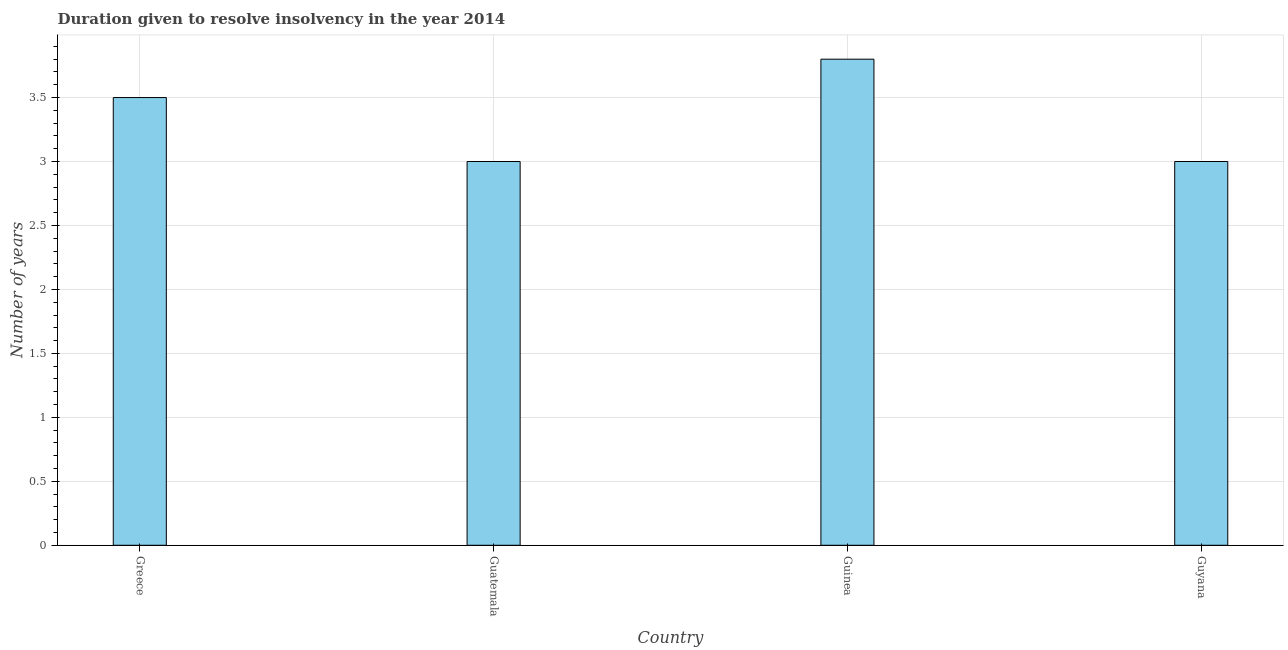Does the graph contain any zero values?
Your response must be concise. No. Does the graph contain grids?
Provide a succinct answer. Yes. What is the title of the graph?
Your response must be concise. Duration given to resolve insolvency in the year 2014. What is the label or title of the X-axis?
Give a very brief answer. Country. What is the label or title of the Y-axis?
Make the answer very short. Number of years. What is the number of years to resolve insolvency in Greece?
Ensure brevity in your answer.  3.5. Across all countries, what is the minimum number of years to resolve insolvency?
Your answer should be compact. 3. In which country was the number of years to resolve insolvency maximum?
Give a very brief answer. Guinea. In which country was the number of years to resolve insolvency minimum?
Provide a succinct answer. Guatemala. What is the average number of years to resolve insolvency per country?
Ensure brevity in your answer.  3.33. What is the median number of years to resolve insolvency?
Your answer should be very brief. 3.25. What is the ratio of the number of years to resolve insolvency in Guatemala to that in Guyana?
Your answer should be compact. 1. Is the number of years to resolve insolvency in Guatemala less than that in Guyana?
Ensure brevity in your answer.  No. Is the difference between the number of years to resolve insolvency in Guinea and Guyana greater than the difference between any two countries?
Provide a succinct answer. Yes. What is the difference between the highest and the second highest number of years to resolve insolvency?
Keep it short and to the point. 0.3. In how many countries, is the number of years to resolve insolvency greater than the average number of years to resolve insolvency taken over all countries?
Your response must be concise. 2. How many bars are there?
Offer a very short reply. 4. Are all the bars in the graph horizontal?
Offer a very short reply. No. How many countries are there in the graph?
Ensure brevity in your answer.  4. What is the difference between two consecutive major ticks on the Y-axis?
Ensure brevity in your answer.  0.5. What is the Number of years in Guinea?
Give a very brief answer. 3.8. What is the Number of years of Guyana?
Give a very brief answer. 3. What is the difference between the Number of years in Guatemala and Guinea?
Make the answer very short. -0.8. What is the difference between the Number of years in Guatemala and Guyana?
Offer a terse response. 0. What is the difference between the Number of years in Guinea and Guyana?
Keep it short and to the point. 0.8. What is the ratio of the Number of years in Greece to that in Guatemala?
Give a very brief answer. 1.17. What is the ratio of the Number of years in Greece to that in Guinea?
Your response must be concise. 0.92. What is the ratio of the Number of years in Greece to that in Guyana?
Offer a very short reply. 1.17. What is the ratio of the Number of years in Guatemala to that in Guinea?
Offer a very short reply. 0.79. What is the ratio of the Number of years in Guinea to that in Guyana?
Offer a very short reply. 1.27. 